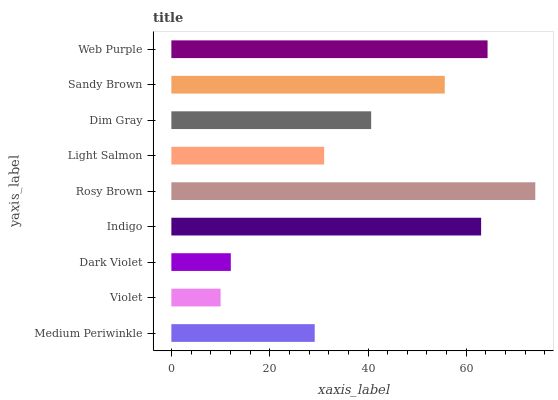Is Violet the minimum?
Answer yes or no. Yes. Is Rosy Brown the maximum?
Answer yes or no. Yes. Is Dark Violet the minimum?
Answer yes or no. No. Is Dark Violet the maximum?
Answer yes or no. No. Is Dark Violet greater than Violet?
Answer yes or no. Yes. Is Violet less than Dark Violet?
Answer yes or no. Yes. Is Violet greater than Dark Violet?
Answer yes or no. No. Is Dark Violet less than Violet?
Answer yes or no. No. Is Dim Gray the high median?
Answer yes or no. Yes. Is Dim Gray the low median?
Answer yes or no. Yes. Is Rosy Brown the high median?
Answer yes or no. No. Is Indigo the low median?
Answer yes or no. No. 